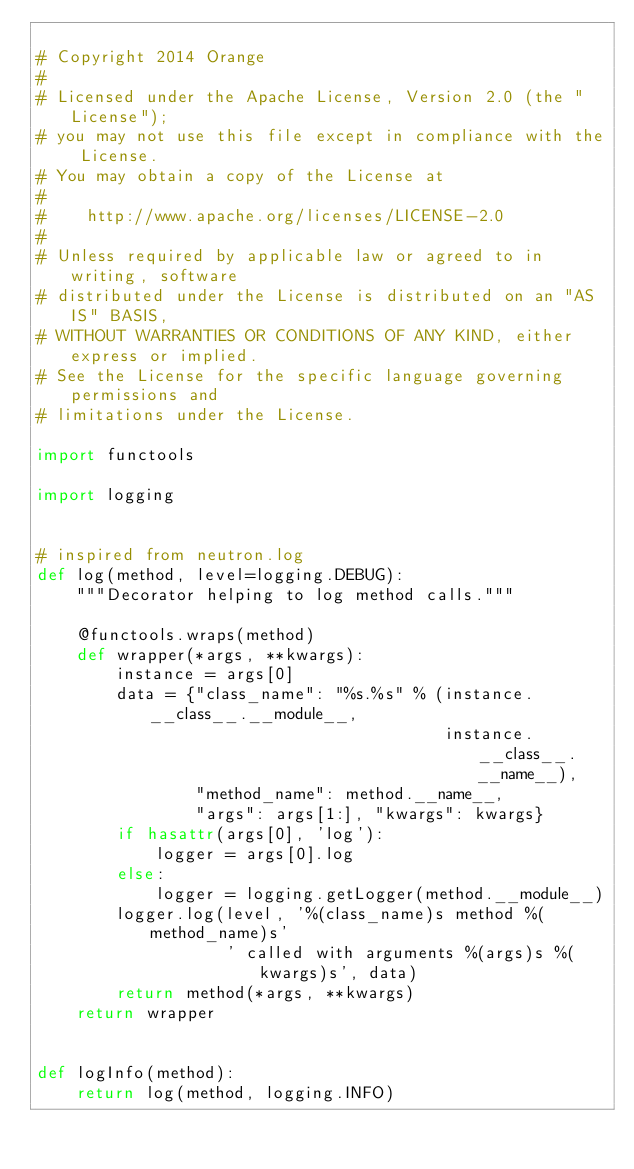<code> <loc_0><loc_0><loc_500><loc_500><_Python_>
# Copyright 2014 Orange
#
# Licensed under the Apache License, Version 2.0 (the "License");
# you may not use this file except in compliance with the License.
# You may obtain a copy of the License at
#
#    http://www.apache.org/licenses/LICENSE-2.0
#
# Unless required by applicable law or agreed to in writing, software
# distributed under the License is distributed on an "AS IS" BASIS,
# WITHOUT WARRANTIES OR CONDITIONS OF ANY KIND, either express or implied.
# See the License for the specific language governing permissions and
# limitations under the License.

import functools

import logging


# inspired from neutron.log
def log(method, level=logging.DEBUG):
    """Decorator helping to log method calls."""

    @functools.wraps(method)
    def wrapper(*args, **kwargs):
        instance = args[0]
        data = {"class_name": "%s.%s" % (instance.__class__.__module__,
                                         instance.__class__.__name__),
                "method_name": method.__name__,
                "args": args[1:], "kwargs": kwargs}
        if hasattr(args[0], 'log'):
            logger = args[0].log
        else:
            logger = logging.getLogger(method.__module__)
        logger.log(level, '%(class_name)s method %(method_name)s'
                   ' called with arguments %(args)s %(kwargs)s', data)
        return method(*args, **kwargs)
    return wrapper


def logInfo(method):
    return log(method, logging.INFO)
</code> 